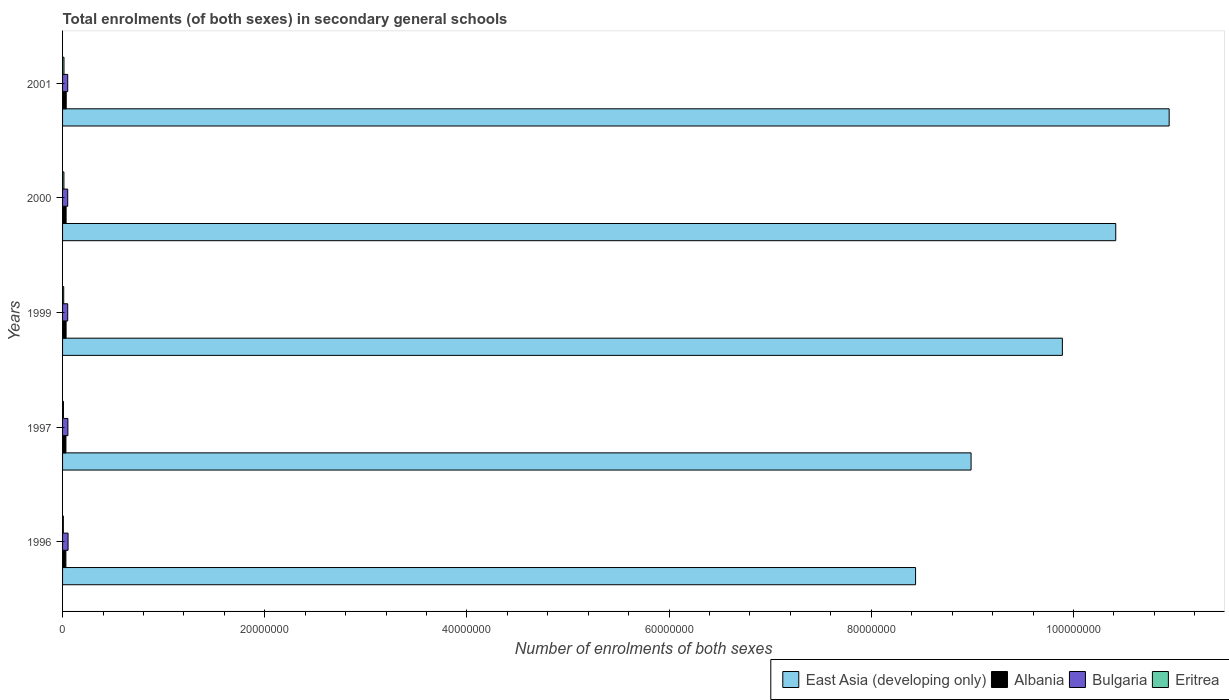How many different coloured bars are there?
Your response must be concise. 4. Are the number of bars on each tick of the Y-axis equal?
Provide a succinct answer. Yes. How many bars are there on the 3rd tick from the top?
Your response must be concise. 4. How many bars are there on the 1st tick from the bottom?
Your answer should be very brief. 4. What is the label of the 5th group of bars from the top?
Provide a short and direct response. 1996. In how many cases, is the number of bars for a given year not equal to the number of legend labels?
Your answer should be compact. 0. What is the number of enrolments in secondary schools in Eritrea in 1997?
Offer a very short reply. 8.81e+04. Across all years, what is the maximum number of enrolments in secondary schools in Albania?
Offer a very short reply. 3.62e+05. Across all years, what is the minimum number of enrolments in secondary schools in Eritrea?
Your answer should be compact. 7.89e+04. In which year was the number of enrolments in secondary schools in Bulgaria maximum?
Your answer should be very brief. 1996. What is the total number of enrolments in secondary schools in Albania in the graph?
Provide a succinct answer. 1.72e+06. What is the difference between the number of enrolments in secondary schools in Albania in 1997 and that in 1999?
Your answer should be very brief. -1.48e+04. What is the difference between the number of enrolments in secondary schools in Albania in 2000 and the number of enrolments in secondary schools in Bulgaria in 2001?
Give a very brief answer. -1.58e+05. What is the average number of enrolments in secondary schools in East Asia (developing only) per year?
Give a very brief answer. 9.74e+07. In the year 2000, what is the difference between the number of enrolments in secondary schools in East Asia (developing only) and number of enrolments in secondary schools in Bulgaria?
Provide a succinct answer. 1.04e+08. What is the ratio of the number of enrolments in secondary schools in East Asia (developing only) in 1996 to that in 2000?
Ensure brevity in your answer.  0.81. Is the number of enrolments in secondary schools in Albania in 1996 less than that in 1999?
Give a very brief answer. Yes. What is the difference between the highest and the second highest number of enrolments in secondary schools in Eritrea?
Ensure brevity in your answer.  6572. What is the difference between the highest and the lowest number of enrolments in secondary schools in East Asia (developing only)?
Give a very brief answer. 2.51e+07. In how many years, is the number of enrolments in secondary schools in Albania greater than the average number of enrolments in secondary schools in Albania taken over all years?
Make the answer very short. 3. Is it the case that in every year, the sum of the number of enrolments in secondary schools in Albania and number of enrolments in secondary schools in Eritrea is greater than the sum of number of enrolments in secondary schools in East Asia (developing only) and number of enrolments in secondary schools in Bulgaria?
Your answer should be compact. No. What does the 2nd bar from the bottom in 2001 represents?
Your response must be concise. Albania. Is it the case that in every year, the sum of the number of enrolments in secondary schools in East Asia (developing only) and number of enrolments in secondary schools in Albania is greater than the number of enrolments in secondary schools in Bulgaria?
Your answer should be compact. Yes. How many bars are there?
Ensure brevity in your answer.  20. What is the difference between two consecutive major ticks on the X-axis?
Provide a succinct answer. 2.00e+07. Are the values on the major ticks of X-axis written in scientific E-notation?
Your answer should be compact. No. How many legend labels are there?
Provide a short and direct response. 4. What is the title of the graph?
Your answer should be very brief. Total enrolments (of both sexes) in secondary general schools. Does "Afghanistan" appear as one of the legend labels in the graph?
Keep it short and to the point. No. What is the label or title of the X-axis?
Make the answer very short. Number of enrolments of both sexes. What is the label or title of the Y-axis?
Make the answer very short. Years. What is the Number of enrolments of both sexes of East Asia (developing only) in 1996?
Provide a succinct answer. 8.44e+07. What is the Number of enrolments of both sexes of Albania in 1996?
Offer a terse response. 3.28e+05. What is the Number of enrolments of both sexes of Bulgaria in 1996?
Ensure brevity in your answer.  5.43e+05. What is the Number of enrolments of both sexes in Eritrea in 1996?
Your answer should be very brief. 7.89e+04. What is the Number of enrolments of both sexes in East Asia (developing only) in 1997?
Make the answer very short. 8.99e+07. What is the Number of enrolments of both sexes in Albania in 1997?
Your answer should be compact. 3.34e+05. What is the Number of enrolments of both sexes of Bulgaria in 1997?
Your response must be concise. 5.27e+05. What is the Number of enrolments of both sexes in Eritrea in 1997?
Give a very brief answer. 8.81e+04. What is the Number of enrolments of both sexes in East Asia (developing only) in 1999?
Your answer should be compact. 9.89e+07. What is the Number of enrolments of both sexes of Albania in 1999?
Keep it short and to the point. 3.48e+05. What is the Number of enrolments of both sexes in Bulgaria in 1999?
Provide a succinct answer. 5.10e+05. What is the Number of enrolments of both sexes in Eritrea in 1999?
Keep it short and to the point. 1.15e+05. What is the Number of enrolments of both sexes of East Asia (developing only) in 2000?
Offer a terse response. 1.04e+08. What is the Number of enrolments of both sexes in Albania in 2000?
Your response must be concise. 3.51e+05. What is the Number of enrolments of both sexes of Bulgaria in 2000?
Offer a very short reply. 5.10e+05. What is the Number of enrolments of both sexes of Eritrea in 2000?
Your answer should be compact. 1.34e+05. What is the Number of enrolments of both sexes of East Asia (developing only) in 2001?
Offer a terse response. 1.09e+08. What is the Number of enrolments of both sexes of Albania in 2001?
Offer a terse response. 3.62e+05. What is the Number of enrolments of both sexes in Bulgaria in 2001?
Offer a terse response. 5.09e+05. What is the Number of enrolments of both sexes of Eritrea in 2001?
Provide a succinct answer. 1.41e+05. Across all years, what is the maximum Number of enrolments of both sexes in East Asia (developing only)?
Give a very brief answer. 1.09e+08. Across all years, what is the maximum Number of enrolments of both sexes in Albania?
Keep it short and to the point. 3.62e+05. Across all years, what is the maximum Number of enrolments of both sexes in Bulgaria?
Give a very brief answer. 5.43e+05. Across all years, what is the maximum Number of enrolments of both sexes in Eritrea?
Make the answer very short. 1.41e+05. Across all years, what is the minimum Number of enrolments of both sexes of East Asia (developing only)?
Provide a short and direct response. 8.44e+07. Across all years, what is the minimum Number of enrolments of both sexes of Albania?
Provide a succinct answer. 3.28e+05. Across all years, what is the minimum Number of enrolments of both sexes in Bulgaria?
Offer a very short reply. 5.09e+05. Across all years, what is the minimum Number of enrolments of both sexes in Eritrea?
Make the answer very short. 7.89e+04. What is the total Number of enrolments of both sexes of East Asia (developing only) in the graph?
Your answer should be compact. 4.87e+08. What is the total Number of enrolments of both sexes of Albania in the graph?
Provide a succinct answer. 1.72e+06. What is the total Number of enrolments of both sexes in Bulgaria in the graph?
Give a very brief answer. 2.60e+06. What is the total Number of enrolments of both sexes in Eritrea in the graph?
Offer a very short reply. 5.56e+05. What is the difference between the Number of enrolments of both sexes of East Asia (developing only) in 1996 and that in 1997?
Make the answer very short. -5.49e+06. What is the difference between the Number of enrolments of both sexes of Albania in 1996 and that in 1997?
Keep it short and to the point. -5082. What is the difference between the Number of enrolments of both sexes in Bulgaria in 1996 and that in 1997?
Give a very brief answer. 1.64e+04. What is the difference between the Number of enrolments of both sexes in Eritrea in 1996 and that in 1997?
Your response must be concise. -9152. What is the difference between the Number of enrolments of both sexes of East Asia (developing only) in 1996 and that in 1999?
Offer a very short reply. -1.45e+07. What is the difference between the Number of enrolments of both sexes of Albania in 1996 and that in 1999?
Ensure brevity in your answer.  -1.99e+04. What is the difference between the Number of enrolments of both sexes in Bulgaria in 1996 and that in 1999?
Offer a very short reply. 3.31e+04. What is the difference between the Number of enrolments of both sexes of Eritrea in 1996 and that in 1999?
Your answer should be compact. -3.57e+04. What is the difference between the Number of enrolments of both sexes of East Asia (developing only) in 1996 and that in 2000?
Ensure brevity in your answer.  -1.98e+07. What is the difference between the Number of enrolments of both sexes in Albania in 1996 and that in 2000?
Give a very brief answer. -2.27e+04. What is the difference between the Number of enrolments of both sexes of Bulgaria in 1996 and that in 2000?
Make the answer very short. 3.29e+04. What is the difference between the Number of enrolments of both sexes in Eritrea in 1996 and that in 2000?
Provide a short and direct response. -5.50e+04. What is the difference between the Number of enrolments of both sexes of East Asia (developing only) in 1996 and that in 2001?
Offer a very short reply. -2.51e+07. What is the difference between the Number of enrolments of both sexes in Albania in 1996 and that in 2001?
Offer a terse response. -3.31e+04. What is the difference between the Number of enrolments of both sexes in Bulgaria in 1996 and that in 2001?
Keep it short and to the point. 3.39e+04. What is the difference between the Number of enrolments of both sexes of Eritrea in 1996 and that in 2001?
Provide a succinct answer. -6.16e+04. What is the difference between the Number of enrolments of both sexes of East Asia (developing only) in 1997 and that in 1999?
Provide a succinct answer. -9.03e+06. What is the difference between the Number of enrolments of both sexes in Albania in 1997 and that in 1999?
Your answer should be very brief. -1.48e+04. What is the difference between the Number of enrolments of both sexes of Bulgaria in 1997 and that in 1999?
Your response must be concise. 1.67e+04. What is the difference between the Number of enrolments of both sexes of Eritrea in 1997 and that in 1999?
Your answer should be very brief. -2.65e+04. What is the difference between the Number of enrolments of both sexes in East Asia (developing only) in 1997 and that in 2000?
Your answer should be compact. -1.43e+07. What is the difference between the Number of enrolments of both sexes of Albania in 1997 and that in 2000?
Keep it short and to the point. -1.76e+04. What is the difference between the Number of enrolments of both sexes of Bulgaria in 1997 and that in 2000?
Make the answer very short. 1.65e+04. What is the difference between the Number of enrolments of both sexes in Eritrea in 1997 and that in 2000?
Make the answer very short. -4.59e+04. What is the difference between the Number of enrolments of both sexes in East Asia (developing only) in 1997 and that in 2001?
Make the answer very short. -1.96e+07. What is the difference between the Number of enrolments of both sexes of Albania in 1997 and that in 2001?
Your answer should be compact. -2.80e+04. What is the difference between the Number of enrolments of both sexes in Bulgaria in 1997 and that in 2001?
Provide a succinct answer. 1.75e+04. What is the difference between the Number of enrolments of both sexes of Eritrea in 1997 and that in 2001?
Your response must be concise. -5.25e+04. What is the difference between the Number of enrolments of both sexes of East Asia (developing only) in 1999 and that in 2000?
Make the answer very short. -5.28e+06. What is the difference between the Number of enrolments of both sexes in Albania in 1999 and that in 2000?
Give a very brief answer. -2794. What is the difference between the Number of enrolments of both sexes in Bulgaria in 1999 and that in 2000?
Make the answer very short. -215. What is the difference between the Number of enrolments of both sexes in Eritrea in 1999 and that in 2000?
Give a very brief answer. -1.94e+04. What is the difference between the Number of enrolments of both sexes of East Asia (developing only) in 1999 and that in 2001?
Your response must be concise. -1.06e+07. What is the difference between the Number of enrolments of both sexes in Albania in 1999 and that in 2001?
Provide a short and direct response. -1.32e+04. What is the difference between the Number of enrolments of both sexes of Bulgaria in 1999 and that in 2001?
Offer a very short reply. 767. What is the difference between the Number of enrolments of both sexes of Eritrea in 1999 and that in 2001?
Ensure brevity in your answer.  -2.60e+04. What is the difference between the Number of enrolments of both sexes of East Asia (developing only) in 2000 and that in 2001?
Make the answer very short. -5.28e+06. What is the difference between the Number of enrolments of both sexes of Albania in 2000 and that in 2001?
Provide a succinct answer. -1.04e+04. What is the difference between the Number of enrolments of both sexes in Bulgaria in 2000 and that in 2001?
Your response must be concise. 982. What is the difference between the Number of enrolments of both sexes of Eritrea in 2000 and that in 2001?
Provide a succinct answer. -6572. What is the difference between the Number of enrolments of both sexes of East Asia (developing only) in 1996 and the Number of enrolments of both sexes of Albania in 1997?
Offer a terse response. 8.41e+07. What is the difference between the Number of enrolments of both sexes of East Asia (developing only) in 1996 and the Number of enrolments of both sexes of Bulgaria in 1997?
Make the answer very short. 8.39e+07. What is the difference between the Number of enrolments of both sexes of East Asia (developing only) in 1996 and the Number of enrolments of both sexes of Eritrea in 1997?
Ensure brevity in your answer.  8.43e+07. What is the difference between the Number of enrolments of both sexes of Albania in 1996 and the Number of enrolments of both sexes of Bulgaria in 1997?
Offer a terse response. -1.98e+05. What is the difference between the Number of enrolments of both sexes in Albania in 1996 and the Number of enrolments of both sexes in Eritrea in 1997?
Your response must be concise. 2.40e+05. What is the difference between the Number of enrolments of both sexes in Bulgaria in 1996 and the Number of enrolments of both sexes in Eritrea in 1997?
Your response must be concise. 4.55e+05. What is the difference between the Number of enrolments of both sexes of East Asia (developing only) in 1996 and the Number of enrolments of both sexes of Albania in 1999?
Offer a very short reply. 8.40e+07. What is the difference between the Number of enrolments of both sexes in East Asia (developing only) in 1996 and the Number of enrolments of both sexes in Bulgaria in 1999?
Ensure brevity in your answer.  8.39e+07. What is the difference between the Number of enrolments of both sexes in East Asia (developing only) in 1996 and the Number of enrolments of both sexes in Eritrea in 1999?
Keep it short and to the point. 8.43e+07. What is the difference between the Number of enrolments of both sexes of Albania in 1996 and the Number of enrolments of both sexes of Bulgaria in 1999?
Make the answer very short. -1.82e+05. What is the difference between the Number of enrolments of both sexes in Albania in 1996 and the Number of enrolments of both sexes in Eritrea in 1999?
Your answer should be compact. 2.14e+05. What is the difference between the Number of enrolments of both sexes of Bulgaria in 1996 and the Number of enrolments of both sexes of Eritrea in 1999?
Your answer should be very brief. 4.29e+05. What is the difference between the Number of enrolments of both sexes of East Asia (developing only) in 1996 and the Number of enrolments of both sexes of Albania in 2000?
Ensure brevity in your answer.  8.40e+07. What is the difference between the Number of enrolments of both sexes of East Asia (developing only) in 1996 and the Number of enrolments of both sexes of Bulgaria in 2000?
Provide a succinct answer. 8.39e+07. What is the difference between the Number of enrolments of both sexes of East Asia (developing only) in 1996 and the Number of enrolments of both sexes of Eritrea in 2000?
Ensure brevity in your answer.  8.43e+07. What is the difference between the Number of enrolments of both sexes of Albania in 1996 and the Number of enrolments of both sexes of Bulgaria in 2000?
Keep it short and to the point. -1.82e+05. What is the difference between the Number of enrolments of both sexes in Albania in 1996 and the Number of enrolments of both sexes in Eritrea in 2000?
Give a very brief answer. 1.94e+05. What is the difference between the Number of enrolments of both sexes of Bulgaria in 1996 and the Number of enrolments of both sexes of Eritrea in 2000?
Provide a short and direct response. 4.09e+05. What is the difference between the Number of enrolments of both sexes in East Asia (developing only) in 1996 and the Number of enrolments of both sexes in Albania in 2001?
Make the answer very short. 8.40e+07. What is the difference between the Number of enrolments of both sexes in East Asia (developing only) in 1996 and the Number of enrolments of both sexes in Bulgaria in 2001?
Your answer should be very brief. 8.39e+07. What is the difference between the Number of enrolments of both sexes of East Asia (developing only) in 1996 and the Number of enrolments of both sexes of Eritrea in 2001?
Provide a succinct answer. 8.42e+07. What is the difference between the Number of enrolments of both sexes of Albania in 1996 and the Number of enrolments of both sexes of Bulgaria in 2001?
Offer a very short reply. -1.81e+05. What is the difference between the Number of enrolments of both sexes in Albania in 1996 and the Number of enrolments of both sexes in Eritrea in 2001?
Keep it short and to the point. 1.88e+05. What is the difference between the Number of enrolments of both sexes in Bulgaria in 1996 and the Number of enrolments of both sexes in Eritrea in 2001?
Your answer should be compact. 4.03e+05. What is the difference between the Number of enrolments of both sexes of East Asia (developing only) in 1997 and the Number of enrolments of both sexes of Albania in 1999?
Ensure brevity in your answer.  8.95e+07. What is the difference between the Number of enrolments of both sexes of East Asia (developing only) in 1997 and the Number of enrolments of both sexes of Bulgaria in 1999?
Make the answer very short. 8.94e+07. What is the difference between the Number of enrolments of both sexes of East Asia (developing only) in 1997 and the Number of enrolments of both sexes of Eritrea in 1999?
Keep it short and to the point. 8.98e+07. What is the difference between the Number of enrolments of both sexes of Albania in 1997 and the Number of enrolments of both sexes of Bulgaria in 1999?
Provide a short and direct response. -1.77e+05. What is the difference between the Number of enrolments of both sexes in Albania in 1997 and the Number of enrolments of both sexes in Eritrea in 1999?
Provide a succinct answer. 2.19e+05. What is the difference between the Number of enrolments of both sexes in Bulgaria in 1997 and the Number of enrolments of both sexes in Eritrea in 1999?
Your answer should be very brief. 4.12e+05. What is the difference between the Number of enrolments of both sexes of East Asia (developing only) in 1997 and the Number of enrolments of both sexes of Albania in 2000?
Your answer should be compact. 8.95e+07. What is the difference between the Number of enrolments of both sexes of East Asia (developing only) in 1997 and the Number of enrolments of both sexes of Bulgaria in 2000?
Keep it short and to the point. 8.94e+07. What is the difference between the Number of enrolments of both sexes in East Asia (developing only) in 1997 and the Number of enrolments of both sexes in Eritrea in 2000?
Provide a short and direct response. 8.97e+07. What is the difference between the Number of enrolments of both sexes of Albania in 1997 and the Number of enrolments of both sexes of Bulgaria in 2000?
Your answer should be very brief. -1.77e+05. What is the difference between the Number of enrolments of both sexes in Albania in 1997 and the Number of enrolments of both sexes in Eritrea in 2000?
Your answer should be compact. 2.00e+05. What is the difference between the Number of enrolments of both sexes in Bulgaria in 1997 and the Number of enrolments of both sexes in Eritrea in 2000?
Offer a terse response. 3.93e+05. What is the difference between the Number of enrolments of both sexes of East Asia (developing only) in 1997 and the Number of enrolments of both sexes of Albania in 2001?
Provide a succinct answer. 8.95e+07. What is the difference between the Number of enrolments of both sexes in East Asia (developing only) in 1997 and the Number of enrolments of both sexes in Bulgaria in 2001?
Offer a terse response. 8.94e+07. What is the difference between the Number of enrolments of both sexes of East Asia (developing only) in 1997 and the Number of enrolments of both sexes of Eritrea in 2001?
Offer a very short reply. 8.97e+07. What is the difference between the Number of enrolments of both sexes of Albania in 1997 and the Number of enrolments of both sexes of Bulgaria in 2001?
Provide a succinct answer. -1.76e+05. What is the difference between the Number of enrolments of both sexes of Albania in 1997 and the Number of enrolments of both sexes of Eritrea in 2001?
Your answer should be very brief. 1.93e+05. What is the difference between the Number of enrolments of both sexes of Bulgaria in 1997 and the Number of enrolments of both sexes of Eritrea in 2001?
Ensure brevity in your answer.  3.86e+05. What is the difference between the Number of enrolments of both sexes in East Asia (developing only) in 1999 and the Number of enrolments of both sexes in Albania in 2000?
Give a very brief answer. 9.86e+07. What is the difference between the Number of enrolments of both sexes in East Asia (developing only) in 1999 and the Number of enrolments of both sexes in Bulgaria in 2000?
Your answer should be very brief. 9.84e+07. What is the difference between the Number of enrolments of both sexes of East Asia (developing only) in 1999 and the Number of enrolments of both sexes of Eritrea in 2000?
Your response must be concise. 9.88e+07. What is the difference between the Number of enrolments of both sexes of Albania in 1999 and the Number of enrolments of both sexes of Bulgaria in 2000?
Ensure brevity in your answer.  -1.62e+05. What is the difference between the Number of enrolments of both sexes in Albania in 1999 and the Number of enrolments of both sexes in Eritrea in 2000?
Your answer should be compact. 2.14e+05. What is the difference between the Number of enrolments of both sexes in Bulgaria in 1999 and the Number of enrolments of both sexes in Eritrea in 2000?
Your answer should be compact. 3.76e+05. What is the difference between the Number of enrolments of both sexes in East Asia (developing only) in 1999 and the Number of enrolments of both sexes in Albania in 2001?
Your answer should be compact. 9.85e+07. What is the difference between the Number of enrolments of both sexes of East Asia (developing only) in 1999 and the Number of enrolments of both sexes of Bulgaria in 2001?
Provide a short and direct response. 9.84e+07. What is the difference between the Number of enrolments of both sexes in East Asia (developing only) in 1999 and the Number of enrolments of both sexes in Eritrea in 2001?
Make the answer very short. 9.88e+07. What is the difference between the Number of enrolments of both sexes in Albania in 1999 and the Number of enrolments of both sexes in Bulgaria in 2001?
Ensure brevity in your answer.  -1.61e+05. What is the difference between the Number of enrolments of both sexes of Albania in 1999 and the Number of enrolments of both sexes of Eritrea in 2001?
Offer a very short reply. 2.08e+05. What is the difference between the Number of enrolments of both sexes of Bulgaria in 1999 and the Number of enrolments of both sexes of Eritrea in 2001?
Provide a short and direct response. 3.70e+05. What is the difference between the Number of enrolments of both sexes in East Asia (developing only) in 2000 and the Number of enrolments of both sexes in Albania in 2001?
Give a very brief answer. 1.04e+08. What is the difference between the Number of enrolments of both sexes of East Asia (developing only) in 2000 and the Number of enrolments of both sexes of Bulgaria in 2001?
Provide a short and direct response. 1.04e+08. What is the difference between the Number of enrolments of both sexes of East Asia (developing only) in 2000 and the Number of enrolments of both sexes of Eritrea in 2001?
Offer a very short reply. 1.04e+08. What is the difference between the Number of enrolments of both sexes of Albania in 2000 and the Number of enrolments of both sexes of Bulgaria in 2001?
Provide a short and direct response. -1.58e+05. What is the difference between the Number of enrolments of both sexes in Albania in 2000 and the Number of enrolments of both sexes in Eritrea in 2001?
Give a very brief answer. 2.11e+05. What is the difference between the Number of enrolments of both sexes of Bulgaria in 2000 and the Number of enrolments of both sexes of Eritrea in 2001?
Provide a succinct answer. 3.70e+05. What is the average Number of enrolments of both sexes of East Asia (developing only) per year?
Your answer should be compact. 9.74e+07. What is the average Number of enrolments of both sexes of Albania per year?
Offer a terse response. 3.45e+05. What is the average Number of enrolments of both sexes in Bulgaria per year?
Make the answer very short. 5.20e+05. What is the average Number of enrolments of both sexes of Eritrea per year?
Ensure brevity in your answer.  1.11e+05. In the year 1996, what is the difference between the Number of enrolments of both sexes in East Asia (developing only) and Number of enrolments of both sexes in Albania?
Make the answer very short. 8.41e+07. In the year 1996, what is the difference between the Number of enrolments of both sexes in East Asia (developing only) and Number of enrolments of both sexes in Bulgaria?
Keep it short and to the point. 8.38e+07. In the year 1996, what is the difference between the Number of enrolments of both sexes in East Asia (developing only) and Number of enrolments of both sexes in Eritrea?
Give a very brief answer. 8.43e+07. In the year 1996, what is the difference between the Number of enrolments of both sexes in Albania and Number of enrolments of both sexes in Bulgaria?
Keep it short and to the point. -2.15e+05. In the year 1996, what is the difference between the Number of enrolments of both sexes in Albania and Number of enrolments of both sexes in Eritrea?
Make the answer very short. 2.50e+05. In the year 1996, what is the difference between the Number of enrolments of both sexes in Bulgaria and Number of enrolments of both sexes in Eritrea?
Your response must be concise. 4.64e+05. In the year 1997, what is the difference between the Number of enrolments of both sexes of East Asia (developing only) and Number of enrolments of both sexes of Albania?
Offer a terse response. 8.95e+07. In the year 1997, what is the difference between the Number of enrolments of both sexes of East Asia (developing only) and Number of enrolments of both sexes of Bulgaria?
Provide a succinct answer. 8.93e+07. In the year 1997, what is the difference between the Number of enrolments of both sexes in East Asia (developing only) and Number of enrolments of both sexes in Eritrea?
Provide a short and direct response. 8.98e+07. In the year 1997, what is the difference between the Number of enrolments of both sexes of Albania and Number of enrolments of both sexes of Bulgaria?
Provide a short and direct response. -1.93e+05. In the year 1997, what is the difference between the Number of enrolments of both sexes of Albania and Number of enrolments of both sexes of Eritrea?
Ensure brevity in your answer.  2.45e+05. In the year 1997, what is the difference between the Number of enrolments of both sexes in Bulgaria and Number of enrolments of both sexes in Eritrea?
Your answer should be very brief. 4.39e+05. In the year 1999, what is the difference between the Number of enrolments of both sexes in East Asia (developing only) and Number of enrolments of both sexes in Albania?
Keep it short and to the point. 9.86e+07. In the year 1999, what is the difference between the Number of enrolments of both sexes in East Asia (developing only) and Number of enrolments of both sexes in Bulgaria?
Keep it short and to the point. 9.84e+07. In the year 1999, what is the difference between the Number of enrolments of both sexes of East Asia (developing only) and Number of enrolments of both sexes of Eritrea?
Your answer should be very brief. 9.88e+07. In the year 1999, what is the difference between the Number of enrolments of both sexes in Albania and Number of enrolments of both sexes in Bulgaria?
Offer a very short reply. -1.62e+05. In the year 1999, what is the difference between the Number of enrolments of both sexes of Albania and Number of enrolments of both sexes of Eritrea?
Keep it short and to the point. 2.34e+05. In the year 1999, what is the difference between the Number of enrolments of both sexes of Bulgaria and Number of enrolments of both sexes of Eritrea?
Provide a short and direct response. 3.96e+05. In the year 2000, what is the difference between the Number of enrolments of both sexes of East Asia (developing only) and Number of enrolments of both sexes of Albania?
Your answer should be compact. 1.04e+08. In the year 2000, what is the difference between the Number of enrolments of both sexes in East Asia (developing only) and Number of enrolments of both sexes in Bulgaria?
Your answer should be very brief. 1.04e+08. In the year 2000, what is the difference between the Number of enrolments of both sexes in East Asia (developing only) and Number of enrolments of both sexes in Eritrea?
Provide a succinct answer. 1.04e+08. In the year 2000, what is the difference between the Number of enrolments of both sexes of Albania and Number of enrolments of both sexes of Bulgaria?
Give a very brief answer. -1.59e+05. In the year 2000, what is the difference between the Number of enrolments of both sexes in Albania and Number of enrolments of both sexes in Eritrea?
Provide a short and direct response. 2.17e+05. In the year 2000, what is the difference between the Number of enrolments of both sexes in Bulgaria and Number of enrolments of both sexes in Eritrea?
Offer a very short reply. 3.76e+05. In the year 2001, what is the difference between the Number of enrolments of both sexes of East Asia (developing only) and Number of enrolments of both sexes of Albania?
Keep it short and to the point. 1.09e+08. In the year 2001, what is the difference between the Number of enrolments of both sexes of East Asia (developing only) and Number of enrolments of both sexes of Bulgaria?
Provide a succinct answer. 1.09e+08. In the year 2001, what is the difference between the Number of enrolments of both sexes in East Asia (developing only) and Number of enrolments of both sexes in Eritrea?
Provide a short and direct response. 1.09e+08. In the year 2001, what is the difference between the Number of enrolments of both sexes of Albania and Number of enrolments of both sexes of Bulgaria?
Give a very brief answer. -1.48e+05. In the year 2001, what is the difference between the Number of enrolments of both sexes in Albania and Number of enrolments of both sexes in Eritrea?
Ensure brevity in your answer.  2.21e+05. In the year 2001, what is the difference between the Number of enrolments of both sexes in Bulgaria and Number of enrolments of both sexes in Eritrea?
Make the answer very short. 3.69e+05. What is the ratio of the Number of enrolments of both sexes of East Asia (developing only) in 1996 to that in 1997?
Offer a very short reply. 0.94. What is the ratio of the Number of enrolments of both sexes of Albania in 1996 to that in 1997?
Provide a short and direct response. 0.98. What is the ratio of the Number of enrolments of both sexes of Bulgaria in 1996 to that in 1997?
Your response must be concise. 1.03. What is the ratio of the Number of enrolments of both sexes in Eritrea in 1996 to that in 1997?
Offer a very short reply. 0.9. What is the ratio of the Number of enrolments of both sexes of East Asia (developing only) in 1996 to that in 1999?
Offer a very short reply. 0.85. What is the ratio of the Number of enrolments of both sexes of Albania in 1996 to that in 1999?
Your answer should be very brief. 0.94. What is the ratio of the Number of enrolments of both sexes in Bulgaria in 1996 to that in 1999?
Your response must be concise. 1.06. What is the ratio of the Number of enrolments of both sexes of Eritrea in 1996 to that in 1999?
Provide a succinct answer. 0.69. What is the ratio of the Number of enrolments of both sexes of East Asia (developing only) in 1996 to that in 2000?
Offer a terse response. 0.81. What is the ratio of the Number of enrolments of both sexes of Albania in 1996 to that in 2000?
Your answer should be very brief. 0.94. What is the ratio of the Number of enrolments of both sexes of Bulgaria in 1996 to that in 2000?
Your answer should be very brief. 1.06. What is the ratio of the Number of enrolments of both sexes of Eritrea in 1996 to that in 2000?
Offer a terse response. 0.59. What is the ratio of the Number of enrolments of both sexes of East Asia (developing only) in 1996 to that in 2001?
Keep it short and to the point. 0.77. What is the ratio of the Number of enrolments of both sexes in Albania in 1996 to that in 2001?
Keep it short and to the point. 0.91. What is the ratio of the Number of enrolments of both sexes in Bulgaria in 1996 to that in 2001?
Make the answer very short. 1.07. What is the ratio of the Number of enrolments of both sexes in Eritrea in 1996 to that in 2001?
Your answer should be compact. 0.56. What is the ratio of the Number of enrolments of both sexes of East Asia (developing only) in 1997 to that in 1999?
Ensure brevity in your answer.  0.91. What is the ratio of the Number of enrolments of both sexes in Albania in 1997 to that in 1999?
Your answer should be compact. 0.96. What is the ratio of the Number of enrolments of both sexes in Bulgaria in 1997 to that in 1999?
Give a very brief answer. 1.03. What is the ratio of the Number of enrolments of both sexes of Eritrea in 1997 to that in 1999?
Your response must be concise. 0.77. What is the ratio of the Number of enrolments of both sexes in East Asia (developing only) in 1997 to that in 2000?
Your answer should be compact. 0.86. What is the ratio of the Number of enrolments of both sexes of Albania in 1997 to that in 2000?
Provide a succinct answer. 0.95. What is the ratio of the Number of enrolments of both sexes in Bulgaria in 1997 to that in 2000?
Make the answer very short. 1.03. What is the ratio of the Number of enrolments of both sexes in Eritrea in 1997 to that in 2000?
Your answer should be very brief. 0.66. What is the ratio of the Number of enrolments of both sexes of East Asia (developing only) in 1997 to that in 2001?
Offer a terse response. 0.82. What is the ratio of the Number of enrolments of both sexes of Albania in 1997 to that in 2001?
Your response must be concise. 0.92. What is the ratio of the Number of enrolments of both sexes in Bulgaria in 1997 to that in 2001?
Ensure brevity in your answer.  1.03. What is the ratio of the Number of enrolments of both sexes of Eritrea in 1997 to that in 2001?
Provide a short and direct response. 0.63. What is the ratio of the Number of enrolments of both sexes of East Asia (developing only) in 1999 to that in 2000?
Ensure brevity in your answer.  0.95. What is the ratio of the Number of enrolments of both sexes in Eritrea in 1999 to that in 2000?
Your answer should be very brief. 0.86. What is the ratio of the Number of enrolments of both sexes of East Asia (developing only) in 1999 to that in 2001?
Provide a short and direct response. 0.9. What is the ratio of the Number of enrolments of both sexes in Albania in 1999 to that in 2001?
Provide a short and direct response. 0.96. What is the ratio of the Number of enrolments of both sexes in Bulgaria in 1999 to that in 2001?
Provide a short and direct response. 1. What is the ratio of the Number of enrolments of both sexes of Eritrea in 1999 to that in 2001?
Offer a terse response. 0.82. What is the ratio of the Number of enrolments of both sexes of East Asia (developing only) in 2000 to that in 2001?
Your answer should be very brief. 0.95. What is the ratio of the Number of enrolments of both sexes of Albania in 2000 to that in 2001?
Make the answer very short. 0.97. What is the ratio of the Number of enrolments of both sexes of Bulgaria in 2000 to that in 2001?
Offer a terse response. 1. What is the ratio of the Number of enrolments of both sexes of Eritrea in 2000 to that in 2001?
Provide a succinct answer. 0.95. What is the difference between the highest and the second highest Number of enrolments of both sexes in East Asia (developing only)?
Provide a short and direct response. 5.28e+06. What is the difference between the highest and the second highest Number of enrolments of both sexes in Albania?
Provide a succinct answer. 1.04e+04. What is the difference between the highest and the second highest Number of enrolments of both sexes in Bulgaria?
Your answer should be compact. 1.64e+04. What is the difference between the highest and the second highest Number of enrolments of both sexes of Eritrea?
Ensure brevity in your answer.  6572. What is the difference between the highest and the lowest Number of enrolments of both sexes in East Asia (developing only)?
Provide a succinct answer. 2.51e+07. What is the difference between the highest and the lowest Number of enrolments of both sexes in Albania?
Your response must be concise. 3.31e+04. What is the difference between the highest and the lowest Number of enrolments of both sexes in Bulgaria?
Provide a short and direct response. 3.39e+04. What is the difference between the highest and the lowest Number of enrolments of both sexes of Eritrea?
Ensure brevity in your answer.  6.16e+04. 